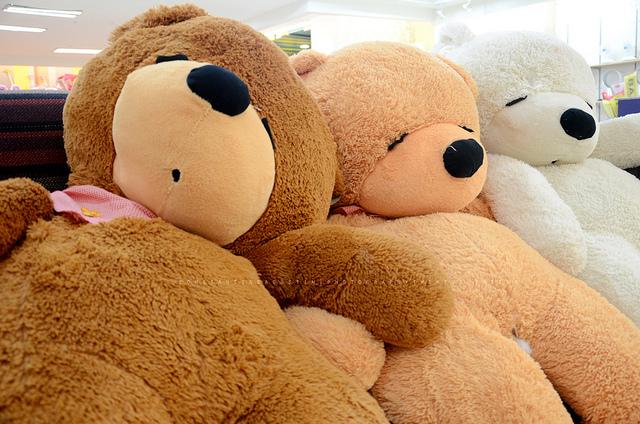How many bears are in the picture?
Keep it brief. 3. Do the bears look like they are asleep?
Answer briefly. Yes. Is the bear on the left bigger than the bear on the right?
Concise answer only. No. Are the bears set up in decreasing darkness of colors?
Answer briefly. Yes. How many teddy bears are there?
Answer briefly. 3. 